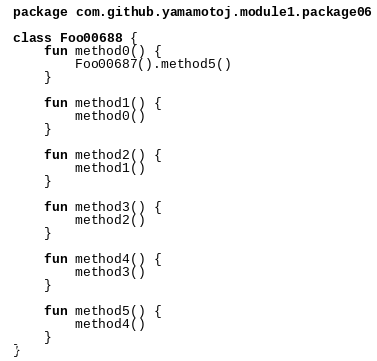<code> <loc_0><loc_0><loc_500><loc_500><_Kotlin_>package com.github.yamamotoj.module1.package06

class Foo00688 {
    fun method0() {
        Foo00687().method5()
    }

    fun method1() {
        method0()
    }

    fun method2() {
        method1()
    }

    fun method3() {
        method2()
    }

    fun method4() {
        method3()
    }

    fun method5() {
        method4()
    }
}
</code> 